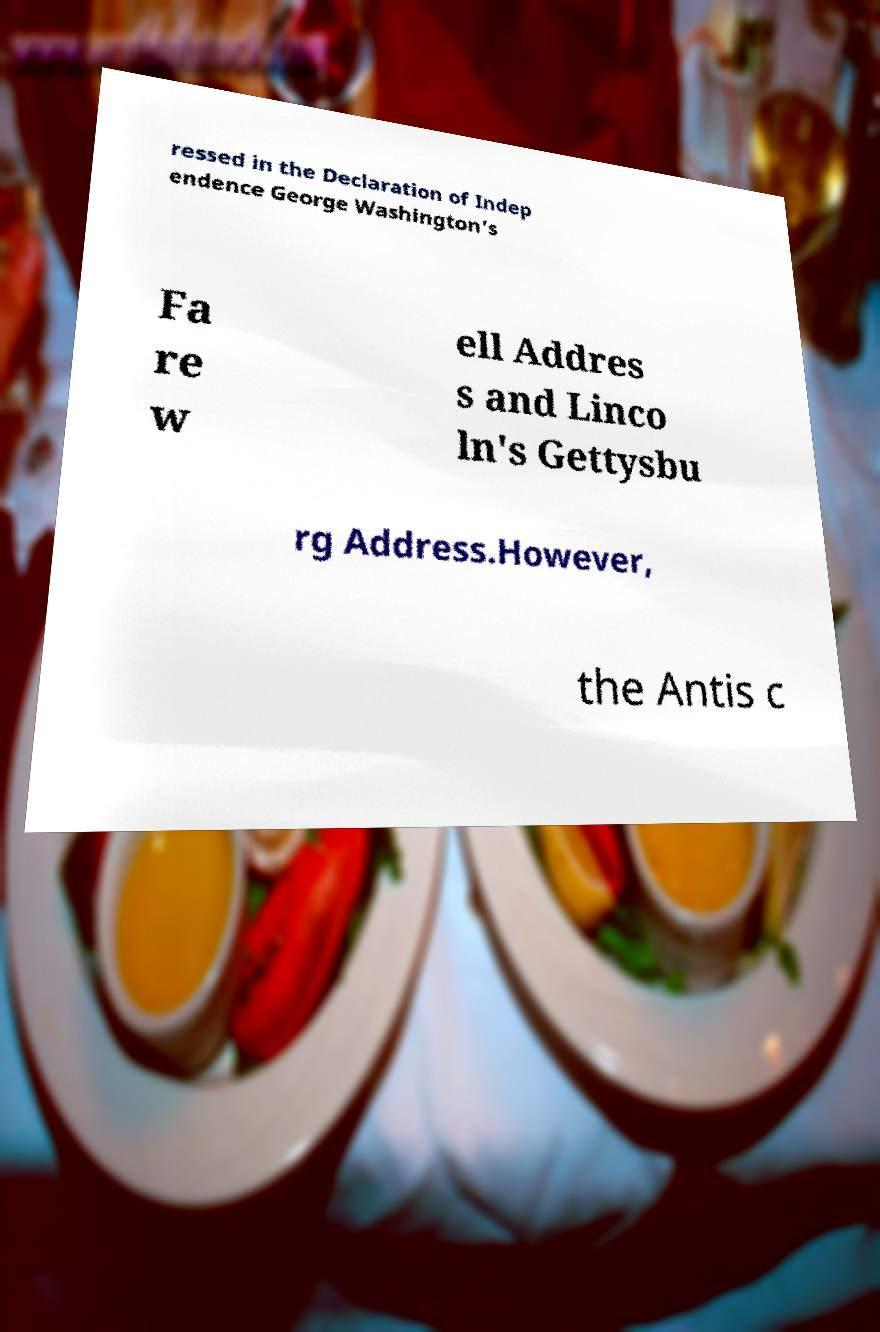Could you extract and type out the text from this image? ressed in the Declaration of Indep endence George Washington's Fa re w ell Addres s and Linco ln's Gettysbu rg Address.However, the Antis c 